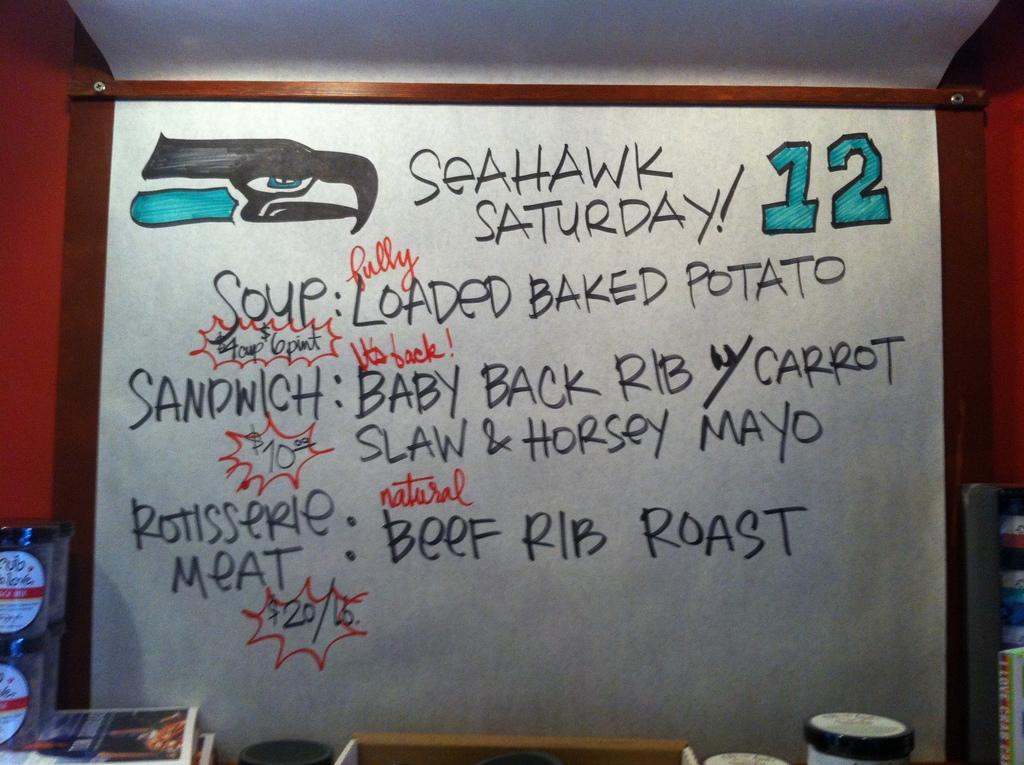<image>
Share a concise interpretation of the image provided. The hand written menu proclaims Seahawk Saturday and that beef rib roast is for sale. 